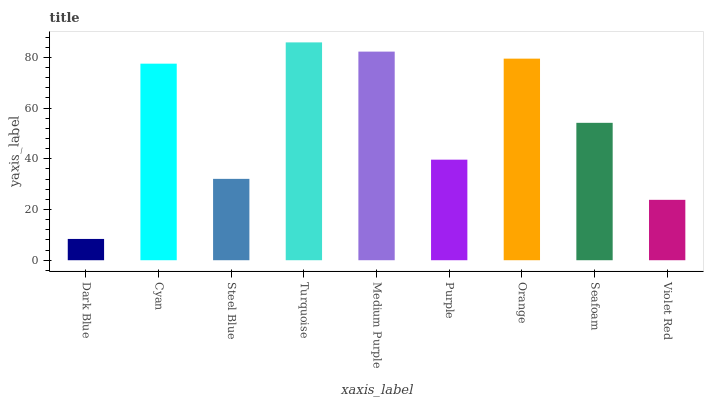Is Cyan the minimum?
Answer yes or no. No. Is Cyan the maximum?
Answer yes or no. No. Is Cyan greater than Dark Blue?
Answer yes or no. Yes. Is Dark Blue less than Cyan?
Answer yes or no. Yes. Is Dark Blue greater than Cyan?
Answer yes or no. No. Is Cyan less than Dark Blue?
Answer yes or no. No. Is Seafoam the high median?
Answer yes or no. Yes. Is Seafoam the low median?
Answer yes or no. Yes. Is Steel Blue the high median?
Answer yes or no. No. Is Dark Blue the low median?
Answer yes or no. No. 